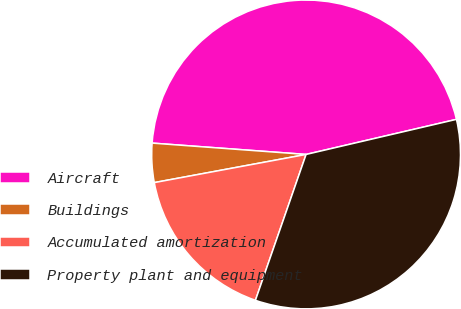Convert chart. <chart><loc_0><loc_0><loc_500><loc_500><pie_chart><fcel>Aircraft<fcel>Buildings<fcel>Accumulated amortization<fcel>Property plant and equipment<nl><fcel>45.18%<fcel>4.09%<fcel>16.76%<fcel>33.97%<nl></chart> 